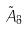Convert formula to latex. <formula><loc_0><loc_0><loc_500><loc_500>\tilde { A } _ { 8 }</formula> 